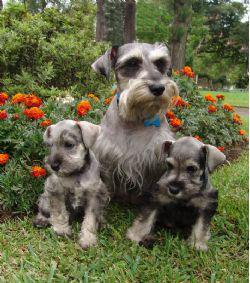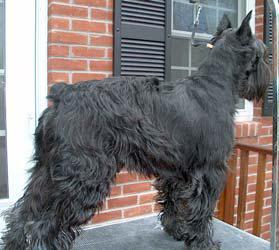The first image is the image on the left, the second image is the image on the right. Assess this claim about the two images: "Both dogs are attached to a leash.". Correct or not? Answer yes or no. No. The first image is the image on the left, the second image is the image on the right. Given the left and right images, does the statement "Each image shows a leash extending from the left to a standing schnauzer dog." hold true? Answer yes or no. No. 